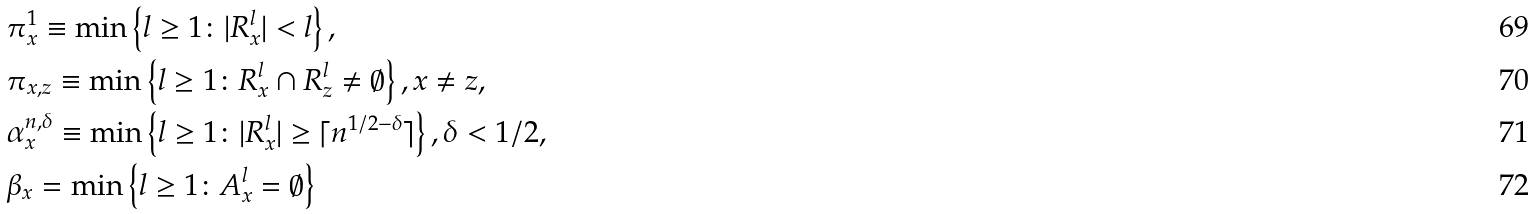<formula> <loc_0><loc_0><loc_500><loc_500>& \pi _ { x } ^ { 1 } \equiv \min \left \{ l \geq 1 \colon | R _ { x } ^ { l } | < l \right \} , \\ & \pi _ { x , z } \equiv \min \left \{ l \geq 1 \colon R _ { x } ^ { l } \cap R _ { z } ^ { l } \neq \emptyset \right \} , x \neq z , \\ & \alpha _ { x } ^ { n , \delta } \equiv \min \left \{ l \geq 1 \colon | R _ { x } ^ { l } | \geq \lceil n ^ { 1 / 2 - \delta } \rceil \right \} , \delta < 1 / 2 , \\ & \beta _ { x } = \min \left \{ l \geq 1 \colon A _ { x } ^ { l } = \emptyset \right \}</formula> 